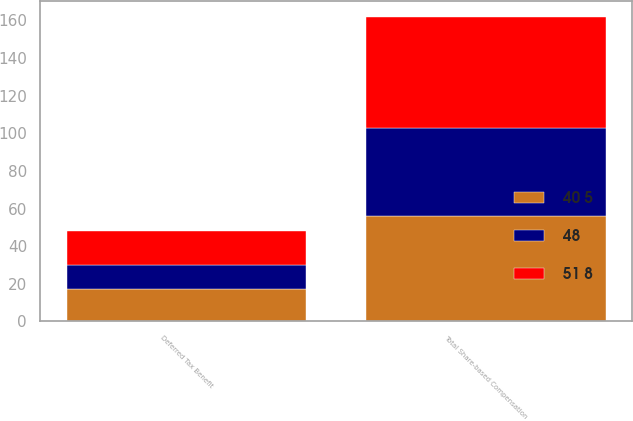Convert chart. <chart><loc_0><loc_0><loc_500><loc_500><stacked_bar_chart><ecel><fcel>Total Share-based Compensation<fcel>Deferred Tax Benefit<nl><fcel>48<fcel>47<fcel>13<nl><fcel>40 5<fcel>56<fcel>17<nl><fcel>51 8<fcel>59<fcel>18<nl></chart> 